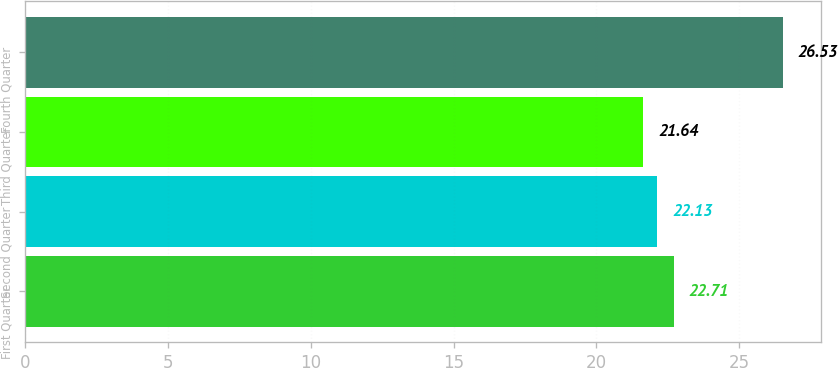<chart> <loc_0><loc_0><loc_500><loc_500><bar_chart><fcel>First Quarter<fcel>Second Quarter<fcel>Third Quarter<fcel>Fourth Quarter<nl><fcel>22.71<fcel>22.13<fcel>21.64<fcel>26.53<nl></chart> 